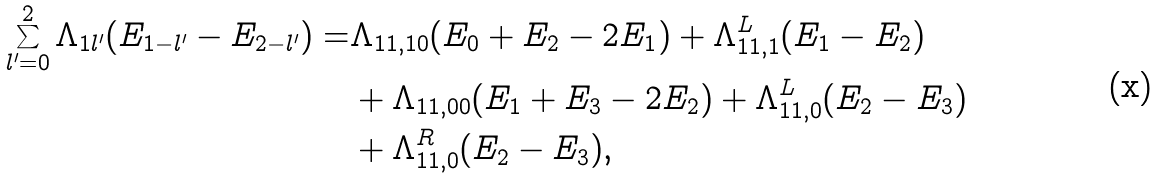Convert formula to latex. <formula><loc_0><loc_0><loc_500><loc_500>\sum _ { l ^ { \prime } = 0 } ^ { 2 } \Lambda _ { 1 l ^ { \prime } } ( E _ { 1 - l ^ { \prime } } - E _ { 2 - l ^ { \prime } } ) = & \Lambda _ { 1 1 , 1 0 } ( E _ { 0 } + E _ { 2 } - 2 E _ { 1 } ) + \Lambda ^ { L } _ { 1 1 , 1 } ( E _ { 1 } - E _ { 2 } ) \\ & + \Lambda _ { 1 1 , 0 0 } ( E _ { 1 } + E _ { 3 } - 2 E _ { 2 } ) + \Lambda ^ { L } _ { 1 1 , 0 } ( E _ { 2 } - E _ { 3 } ) \\ & + \Lambda ^ { R } _ { 1 1 , 0 } ( E _ { 2 } - E _ { 3 } ) ,</formula> 